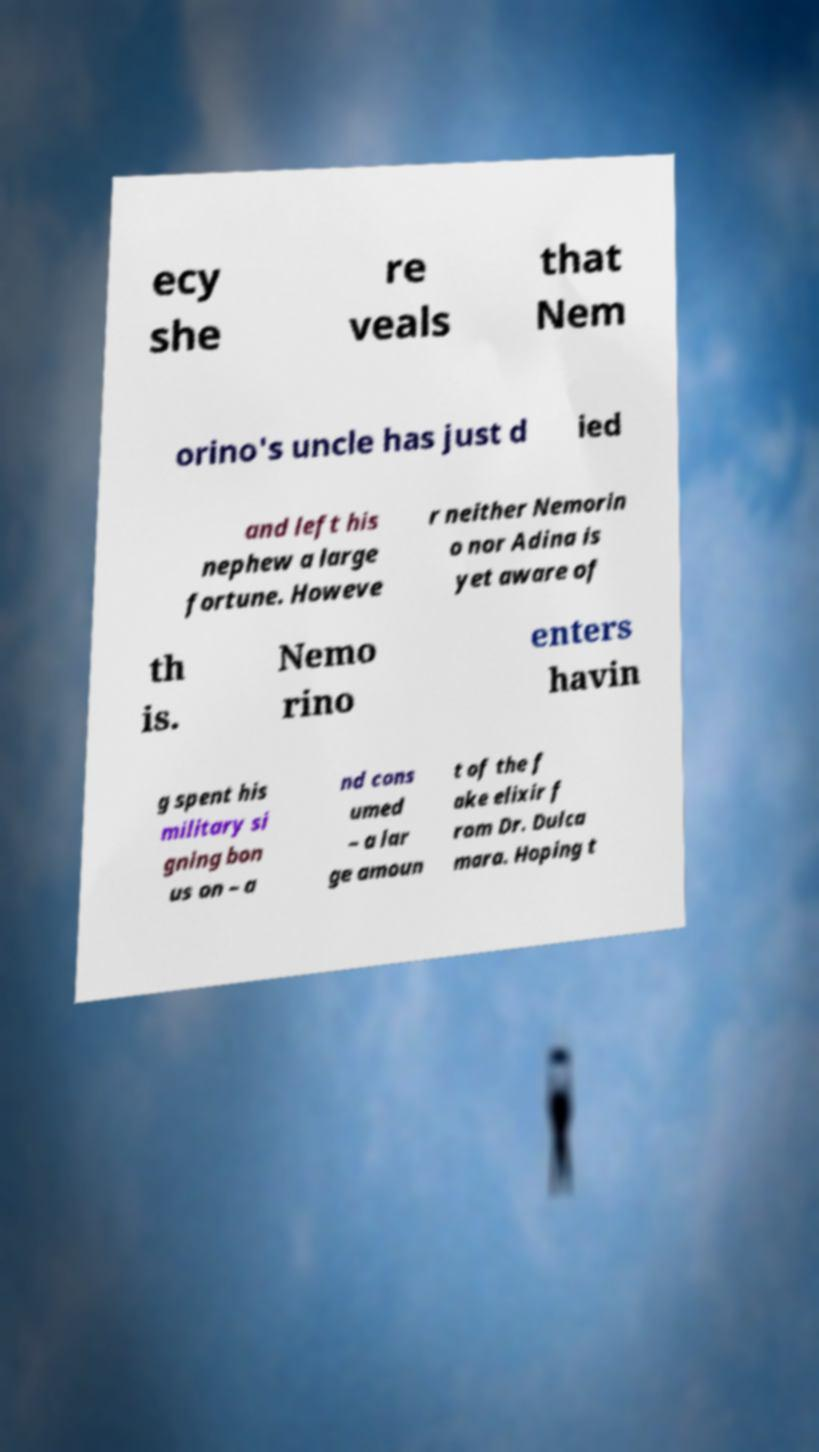Could you assist in decoding the text presented in this image and type it out clearly? ecy she re veals that Nem orino's uncle has just d ied and left his nephew a large fortune. Howeve r neither Nemorin o nor Adina is yet aware of th is. Nemo rino enters havin g spent his military si gning bon us on – a nd cons umed – a lar ge amoun t of the f ake elixir f rom Dr. Dulca mara. Hoping t 